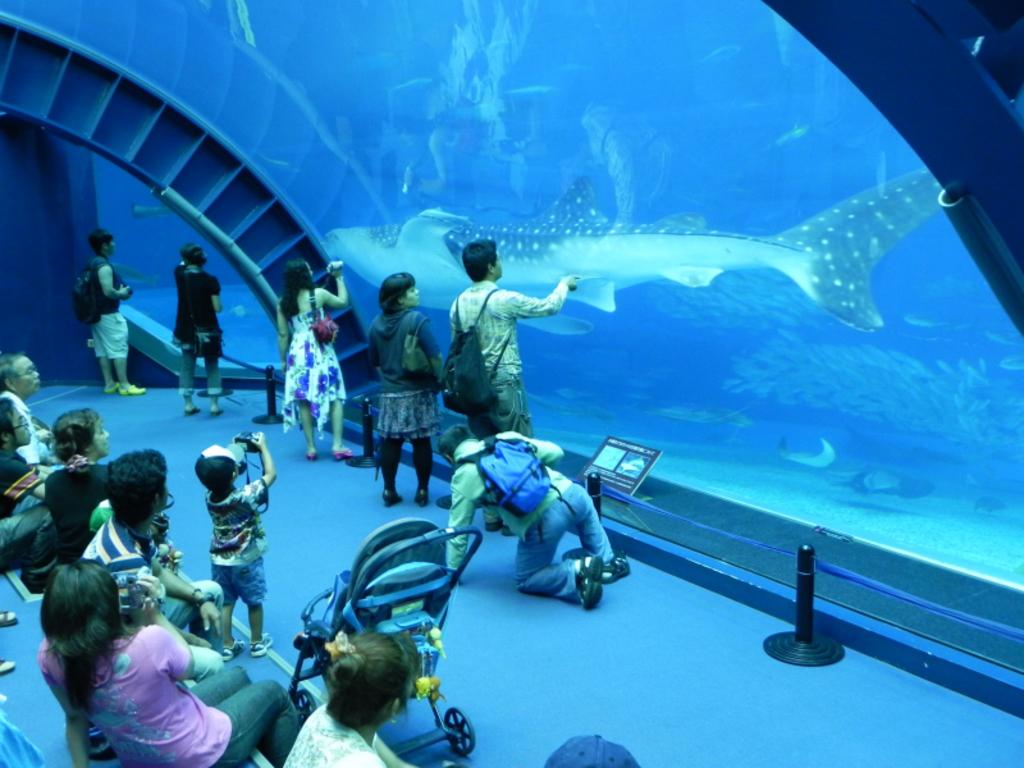Who or what can be seen on the left side of the image? There are people on the left side of the image. What is visible in the background of the image? There is a fish visible in the background of the image. What type of lettuce is being used as a kite in the image? There is no lettuce or kite present in the image. 